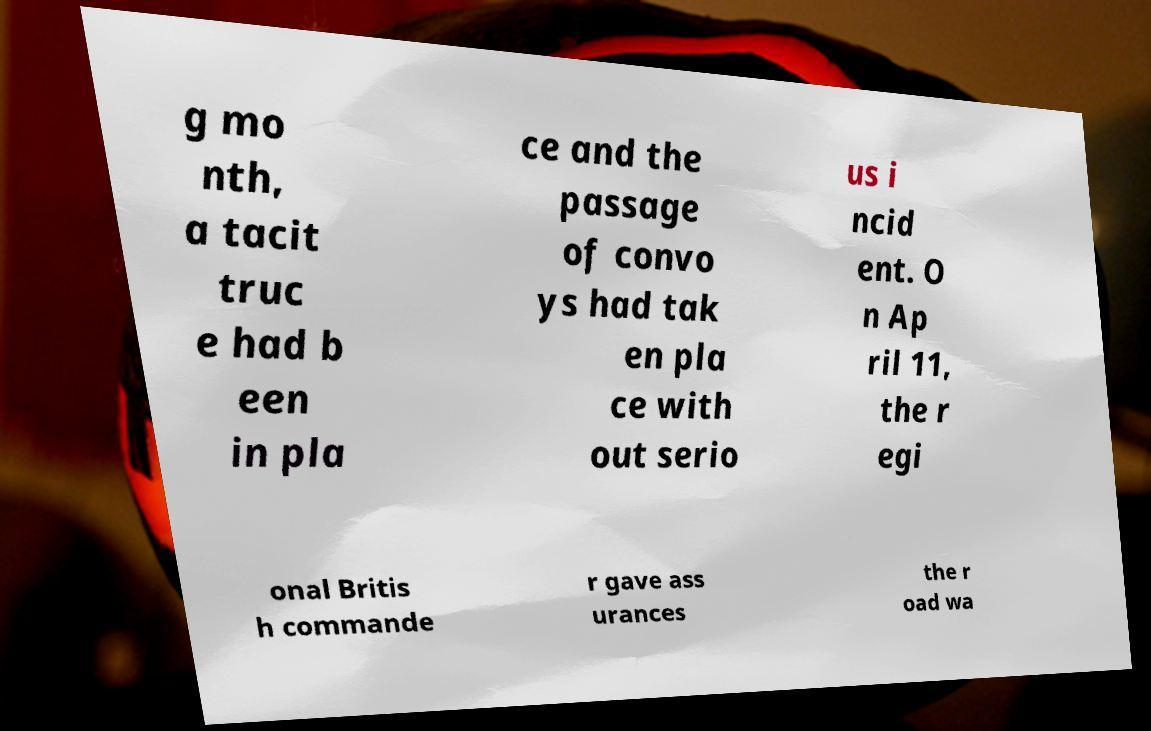What messages or text are displayed in this image? I need them in a readable, typed format. g mo nth, a tacit truc e had b een in pla ce and the passage of convo ys had tak en pla ce with out serio us i ncid ent. O n Ap ril 11, the r egi onal Britis h commande r gave ass urances the r oad wa 